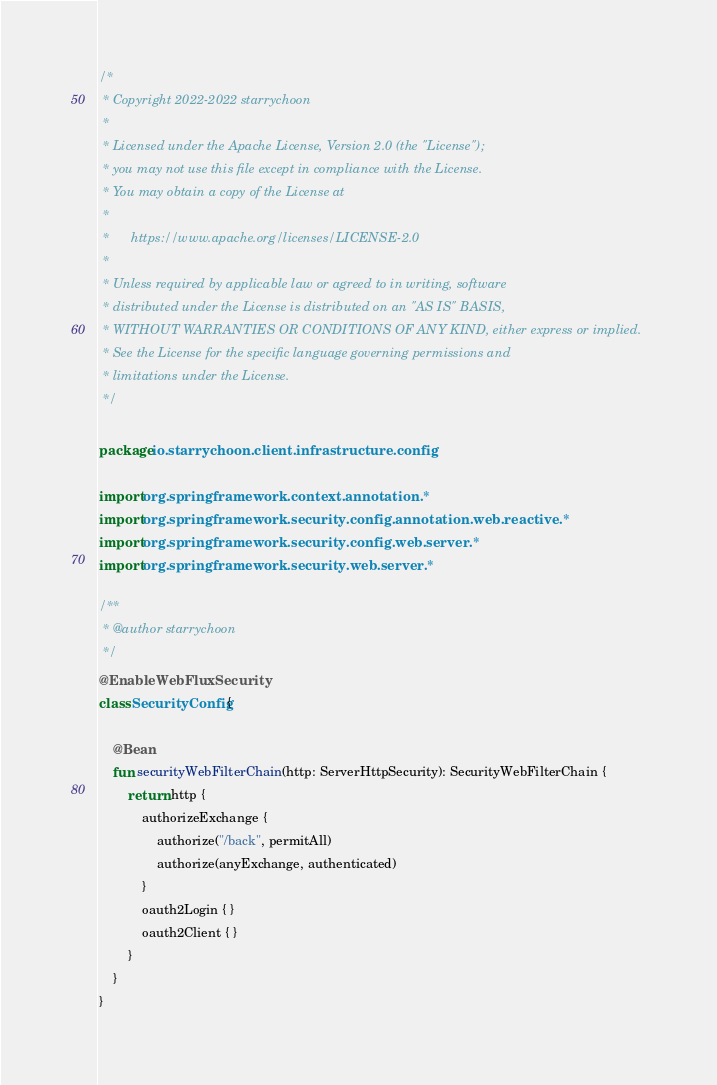<code> <loc_0><loc_0><loc_500><loc_500><_Kotlin_>/*
 * Copyright 2022-2022 starrychoon
 *
 * Licensed under the Apache License, Version 2.0 (the "License");
 * you may not use this file except in compliance with the License.
 * You may obtain a copy of the License at
 *
 *      https://www.apache.org/licenses/LICENSE-2.0
 *
 * Unless required by applicable law or agreed to in writing, software
 * distributed under the License is distributed on an "AS IS" BASIS,
 * WITHOUT WARRANTIES OR CONDITIONS OF ANY KIND, either express or implied.
 * See the License for the specific language governing permissions and
 * limitations under the License.
 */

package io.starrychoon.client.infrastructure.config

import org.springframework.context.annotation.*
import org.springframework.security.config.annotation.web.reactive.*
import org.springframework.security.config.web.server.*
import org.springframework.security.web.server.*

/**
 * @author starrychoon
 */
@EnableWebFluxSecurity
class SecurityConfig {

    @Bean
    fun securityWebFilterChain(http: ServerHttpSecurity): SecurityWebFilterChain {
        return http {
            authorizeExchange {
                authorize("/back", permitAll)
                authorize(anyExchange, authenticated)
            }
            oauth2Login { }
            oauth2Client { }
        }
    }
}
</code> 